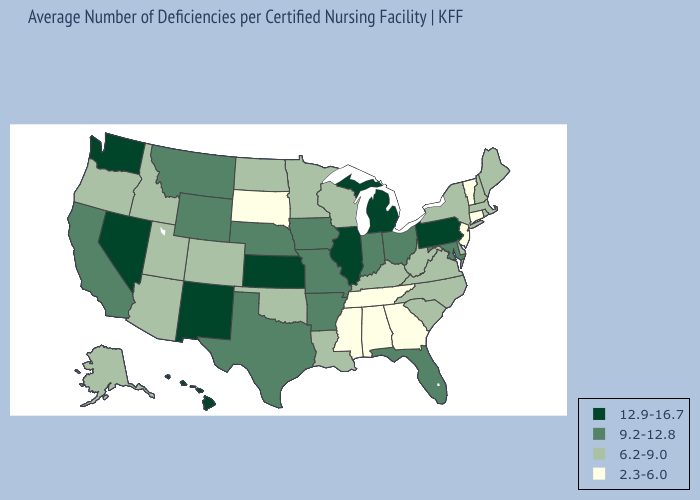Name the states that have a value in the range 9.2-12.8?
Concise answer only. Arkansas, California, Florida, Indiana, Iowa, Maryland, Missouri, Montana, Nebraska, Ohio, Texas, Wyoming. Does West Virginia have a lower value than Vermont?
Short answer required. No. Name the states that have a value in the range 9.2-12.8?
Keep it brief. Arkansas, California, Florida, Indiana, Iowa, Maryland, Missouri, Montana, Nebraska, Ohio, Texas, Wyoming. What is the highest value in the MidWest ?
Keep it brief. 12.9-16.7. Name the states that have a value in the range 9.2-12.8?
Concise answer only. Arkansas, California, Florida, Indiana, Iowa, Maryland, Missouri, Montana, Nebraska, Ohio, Texas, Wyoming. Name the states that have a value in the range 6.2-9.0?
Keep it brief. Alaska, Arizona, Colorado, Delaware, Idaho, Kentucky, Louisiana, Maine, Massachusetts, Minnesota, New Hampshire, New York, North Carolina, North Dakota, Oklahoma, Oregon, Rhode Island, South Carolina, Utah, Virginia, West Virginia, Wisconsin. What is the highest value in states that border Indiana?
Quick response, please. 12.9-16.7. What is the value of Texas?
Be succinct. 9.2-12.8. Does Oklahoma have the highest value in the South?
Be succinct. No. Name the states that have a value in the range 9.2-12.8?
Write a very short answer. Arkansas, California, Florida, Indiana, Iowa, Maryland, Missouri, Montana, Nebraska, Ohio, Texas, Wyoming. Does the first symbol in the legend represent the smallest category?
Be succinct. No. What is the value of Vermont?
Be succinct. 2.3-6.0. What is the value of Colorado?
Write a very short answer. 6.2-9.0. Name the states that have a value in the range 12.9-16.7?
Answer briefly. Hawaii, Illinois, Kansas, Michigan, Nevada, New Mexico, Pennsylvania, Washington. What is the lowest value in states that border Arkansas?
Concise answer only. 2.3-6.0. 